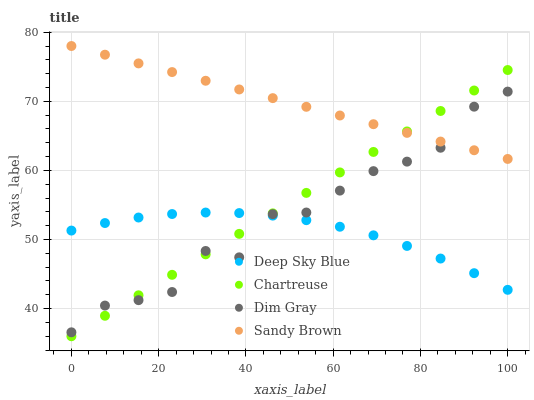Does Deep Sky Blue have the minimum area under the curve?
Answer yes or no. Yes. Does Sandy Brown have the maximum area under the curve?
Answer yes or no. Yes. Does Dim Gray have the minimum area under the curve?
Answer yes or no. No. Does Dim Gray have the maximum area under the curve?
Answer yes or no. No. Is Chartreuse the smoothest?
Answer yes or no. Yes. Is Dim Gray the roughest?
Answer yes or no. Yes. Is Sandy Brown the smoothest?
Answer yes or no. No. Is Sandy Brown the roughest?
Answer yes or no. No. Does Chartreuse have the lowest value?
Answer yes or no. Yes. Does Dim Gray have the lowest value?
Answer yes or no. No. Does Sandy Brown have the highest value?
Answer yes or no. Yes. Does Dim Gray have the highest value?
Answer yes or no. No. Is Deep Sky Blue less than Sandy Brown?
Answer yes or no. Yes. Is Sandy Brown greater than Deep Sky Blue?
Answer yes or no. Yes. Does Dim Gray intersect Deep Sky Blue?
Answer yes or no. Yes. Is Dim Gray less than Deep Sky Blue?
Answer yes or no. No. Is Dim Gray greater than Deep Sky Blue?
Answer yes or no. No. Does Deep Sky Blue intersect Sandy Brown?
Answer yes or no. No. 